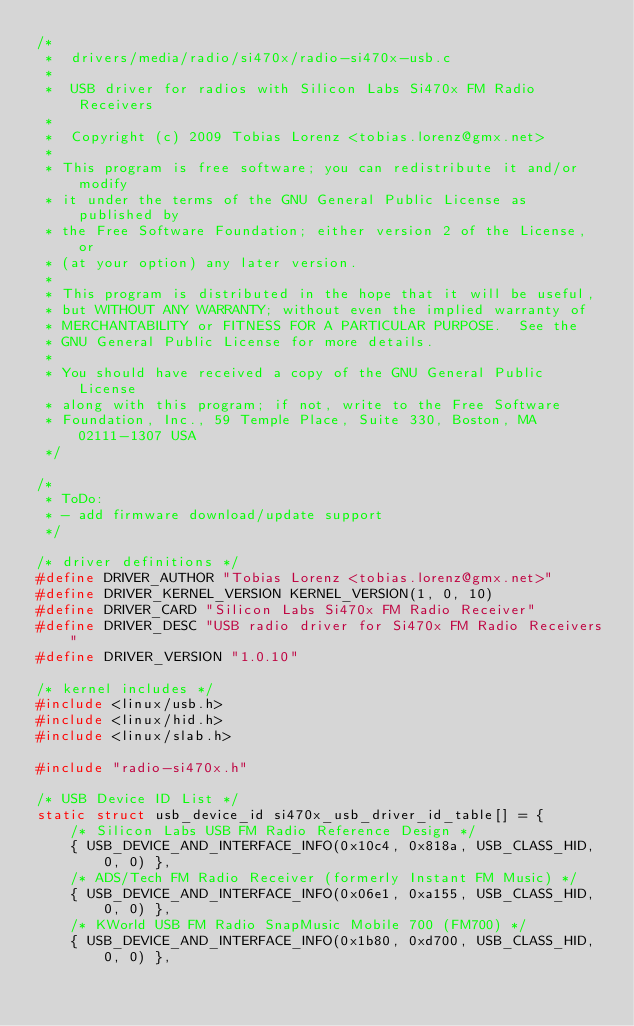<code> <loc_0><loc_0><loc_500><loc_500><_C_>/*
 *  drivers/media/radio/si470x/radio-si470x-usb.c
 *
 *  USB driver for radios with Silicon Labs Si470x FM Radio Receivers
 *
 *  Copyright (c) 2009 Tobias Lorenz <tobias.lorenz@gmx.net>
 *
 * This program is free software; you can redistribute it and/or modify
 * it under the terms of the GNU General Public License as published by
 * the Free Software Foundation; either version 2 of the License, or
 * (at your option) any later version.
 *
 * This program is distributed in the hope that it will be useful,
 * but WITHOUT ANY WARRANTY; without even the implied warranty of
 * MERCHANTABILITY or FITNESS FOR A PARTICULAR PURPOSE.  See the
 * GNU General Public License for more details.
 *
 * You should have received a copy of the GNU General Public License
 * along with this program; if not, write to the Free Software
 * Foundation, Inc., 59 Temple Place, Suite 330, Boston, MA 02111-1307 USA
 */

/*
 * ToDo:
 * - add firmware download/update support
 */

/* driver definitions */
#define DRIVER_AUTHOR "Tobias Lorenz <tobias.lorenz@gmx.net>"
#define DRIVER_KERNEL_VERSION KERNEL_VERSION(1, 0, 10)
#define DRIVER_CARD "Silicon Labs Si470x FM Radio Receiver"
#define DRIVER_DESC "USB radio driver for Si470x FM Radio Receivers"
#define DRIVER_VERSION "1.0.10"

/* kernel includes */
#include <linux/usb.h>
#include <linux/hid.h>
#include <linux/slab.h>

#include "radio-si470x.h"

/* USB Device ID List */
static struct usb_device_id si470x_usb_driver_id_table[] = {
	/* Silicon Labs USB FM Radio Reference Design */
	{ USB_DEVICE_AND_INTERFACE_INFO(0x10c4, 0x818a, USB_CLASS_HID, 0, 0) },
	/* ADS/Tech FM Radio Receiver (formerly Instant FM Music) */
	{ USB_DEVICE_AND_INTERFACE_INFO(0x06e1, 0xa155, USB_CLASS_HID, 0, 0) },
	/* KWorld USB FM Radio SnapMusic Mobile 700 (FM700) */
	{ USB_DEVICE_AND_INTERFACE_INFO(0x1b80, 0xd700, USB_CLASS_HID, 0, 0) },</code> 